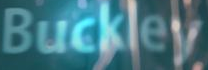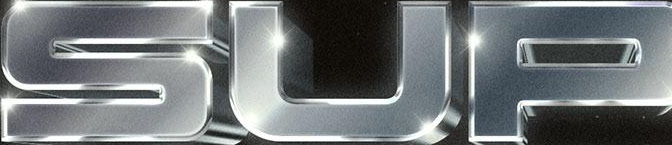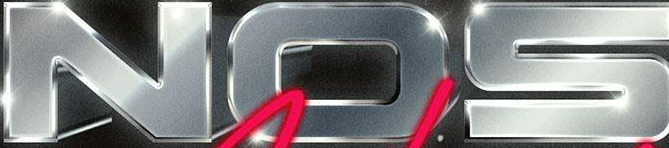Transcribe the words shown in these images in order, separated by a semicolon. Buckley; SUP; NOS 